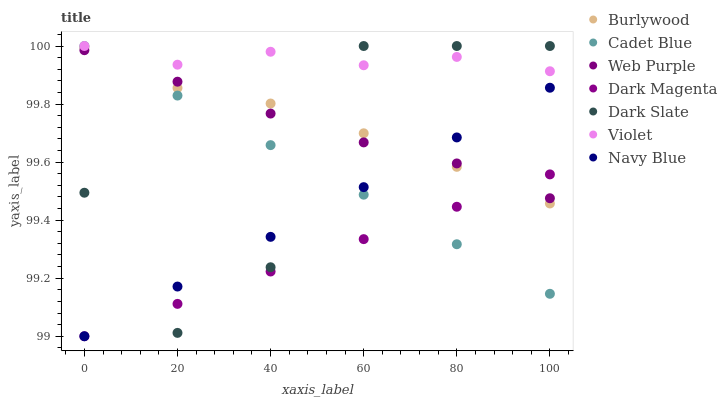Does Dark Magenta have the minimum area under the curve?
Answer yes or no. Yes. Does Violet have the maximum area under the curve?
Answer yes or no. Yes. Does Burlywood have the minimum area under the curve?
Answer yes or no. No. Does Burlywood have the maximum area under the curve?
Answer yes or no. No. Is Navy Blue the smoothest?
Answer yes or no. Yes. Is Dark Slate the roughest?
Answer yes or no. Yes. Is Dark Magenta the smoothest?
Answer yes or no. No. Is Dark Magenta the roughest?
Answer yes or no. No. Does Dark Magenta have the lowest value?
Answer yes or no. Yes. Does Burlywood have the lowest value?
Answer yes or no. No. Does Violet have the highest value?
Answer yes or no. Yes. Does Burlywood have the highest value?
Answer yes or no. No. Is Burlywood less than Violet?
Answer yes or no. Yes. Is Violet greater than Dark Magenta?
Answer yes or no. Yes. Does Burlywood intersect Dark Slate?
Answer yes or no. Yes. Is Burlywood less than Dark Slate?
Answer yes or no. No. Is Burlywood greater than Dark Slate?
Answer yes or no. No. Does Burlywood intersect Violet?
Answer yes or no. No. 